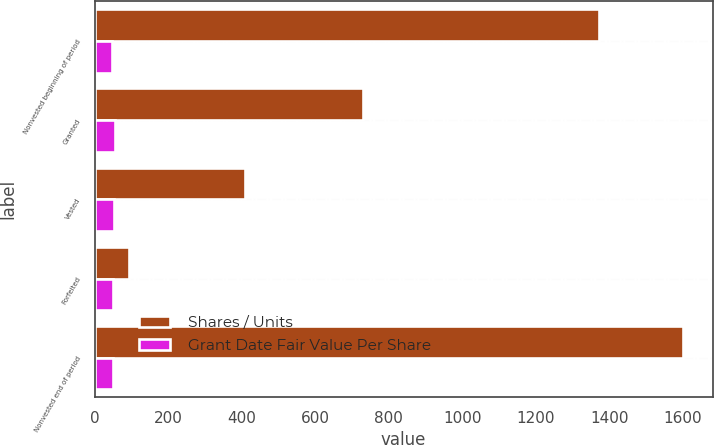Convert chart. <chart><loc_0><loc_0><loc_500><loc_500><stacked_bar_chart><ecel><fcel>Nonvested beginning of period<fcel>Granted<fcel>Vested<fcel>Forfeited<fcel>Nonvested end of period<nl><fcel>Shares / Units<fcel>1371<fcel>730<fcel>408<fcel>92<fcel>1601<nl><fcel>Grant Date Fair Value Per Share<fcel>46<fcel>56<fcel>51<fcel>50<fcel>49<nl></chart> 